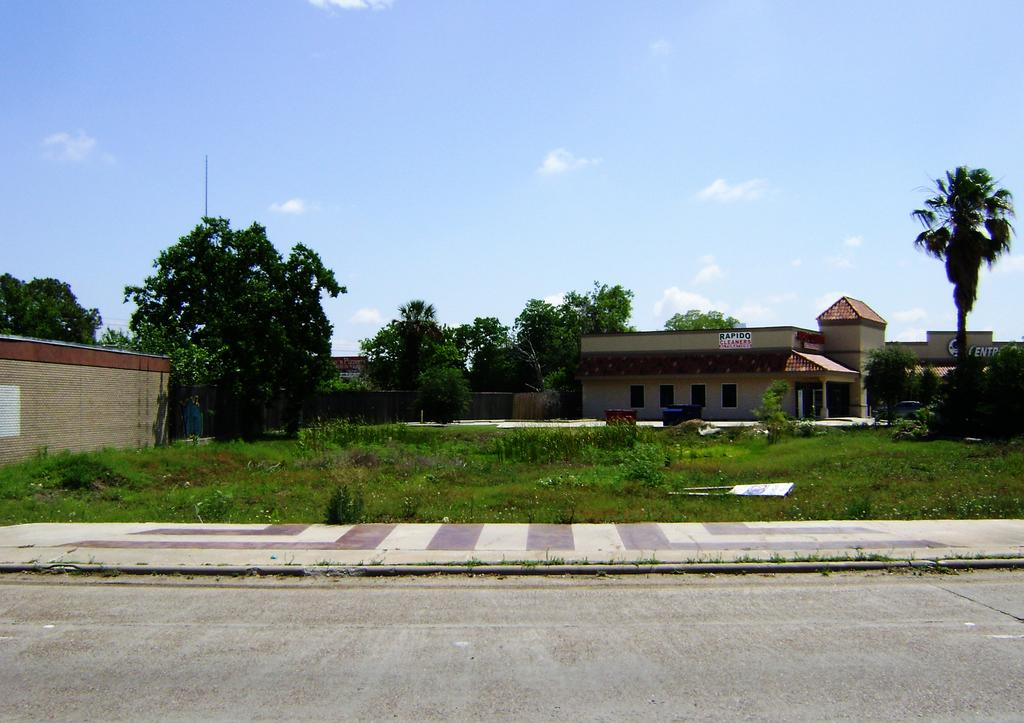What type of structures are visible in the image? There are houses in the image. What is located in front of the houses? There are plants and grass in front of the houses. What is located behind the houses? There are trees behind the houses. What is visible at the top of the image? The sky is visible in the image. What type of plastic is used to make the wine bottles in the image? There are no wine bottles present in the image, so it is not possible to determine the type of plastic used. 